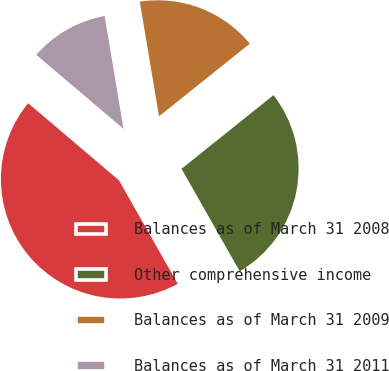Convert chart. <chart><loc_0><loc_0><loc_500><loc_500><pie_chart><fcel>Balances as of March 31 2008<fcel>Other comprehensive income<fcel>Balances as of March 31 2009<fcel>Balances as of March 31 2011<nl><fcel>44.42%<fcel>27.52%<fcel>16.9%<fcel>11.15%<nl></chart> 